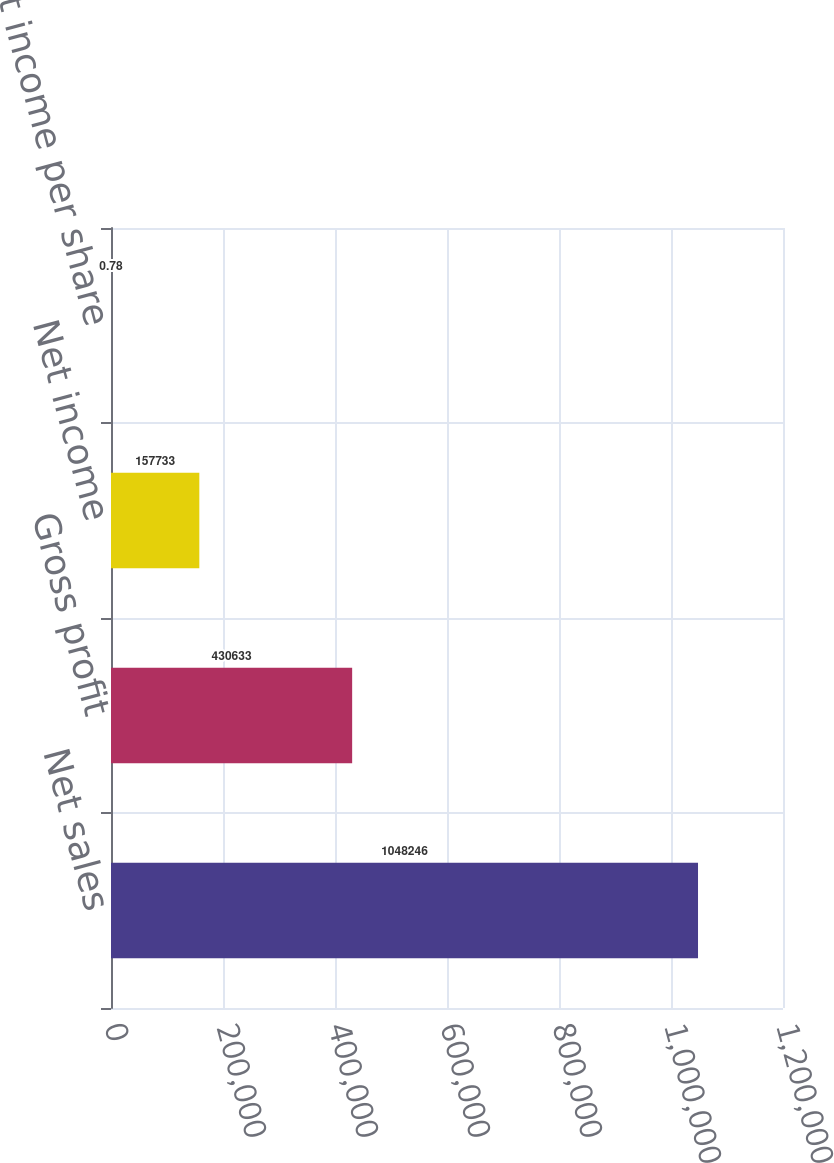Convert chart to OTSL. <chart><loc_0><loc_0><loc_500><loc_500><bar_chart><fcel>Net sales<fcel>Gross profit<fcel>Net income<fcel>Basic net income per share<nl><fcel>1.04825e+06<fcel>430633<fcel>157733<fcel>0.78<nl></chart> 